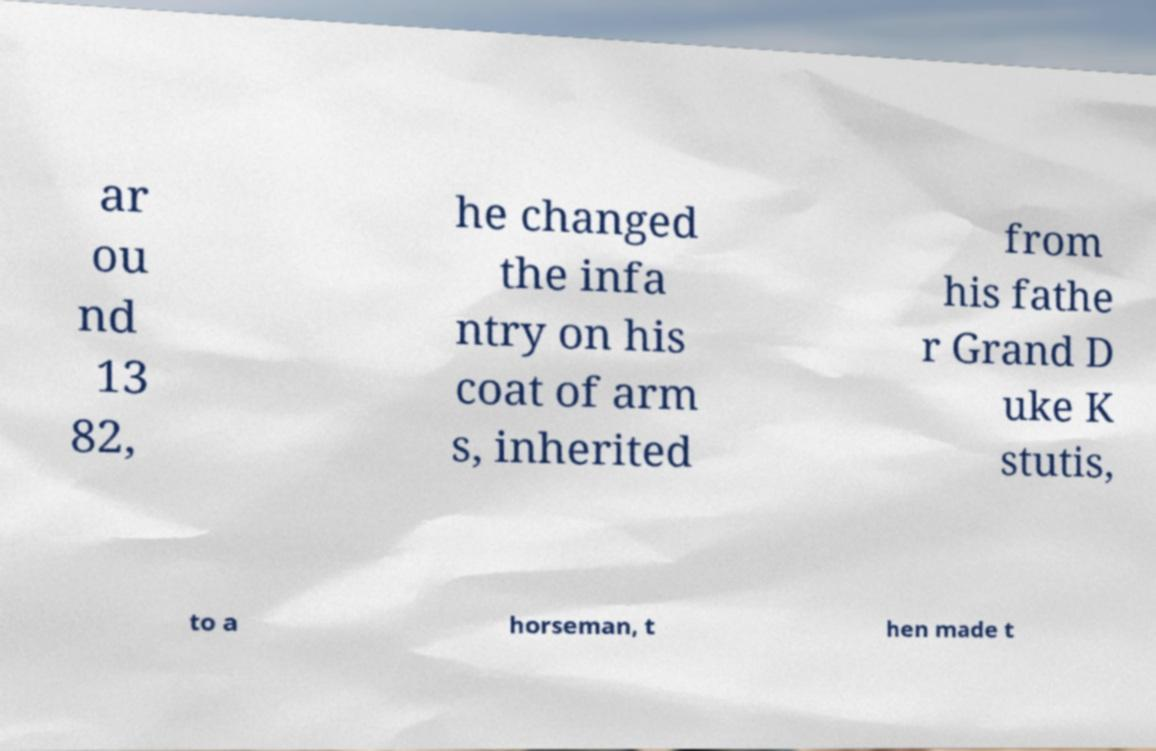There's text embedded in this image that I need extracted. Can you transcribe it verbatim? ar ou nd 13 82, he changed the infa ntry on his coat of arm s, inherited from his fathe r Grand D uke K stutis, to a horseman, t hen made t 